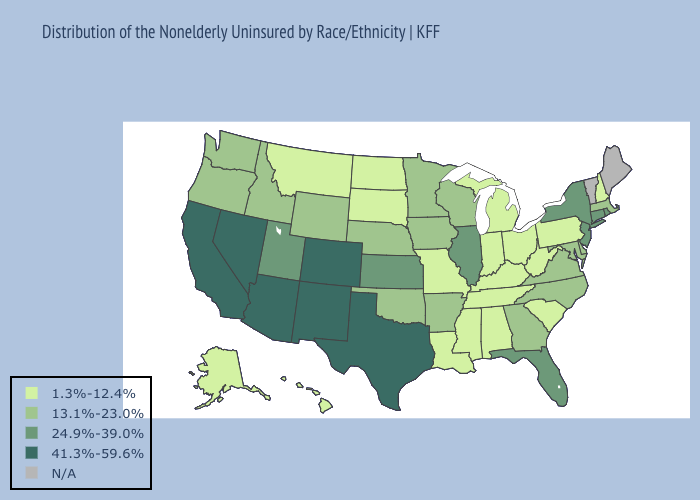Which states hav the highest value in the Northeast?
Answer briefly. Connecticut, New Jersey, New York, Rhode Island. Does Oregon have the highest value in the USA?
Short answer required. No. Name the states that have a value in the range 24.9%-39.0%?
Short answer required. Connecticut, Florida, Illinois, Kansas, New Jersey, New York, Rhode Island, Utah. Is the legend a continuous bar?
Be succinct. No. What is the highest value in states that border North Dakota?
Concise answer only. 13.1%-23.0%. What is the highest value in the South ?
Be succinct. 41.3%-59.6%. Does Montana have the lowest value in the West?
Give a very brief answer. Yes. Which states hav the highest value in the West?
Short answer required. Arizona, California, Colorado, Nevada, New Mexico. What is the value of Rhode Island?
Write a very short answer. 24.9%-39.0%. What is the value of South Dakota?
Keep it brief. 1.3%-12.4%. Name the states that have a value in the range 13.1%-23.0%?
Keep it brief. Arkansas, Delaware, Georgia, Idaho, Iowa, Maryland, Massachusetts, Minnesota, Nebraska, North Carolina, Oklahoma, Oregon, Virginia, Washington, Wisconsin, Wyoming. How many symbols are there in the legend?
Write a very short answer. 5. What is the value of Montana?
Quick response, please. 1.3%-12.4%. Which states have the highest value in the USA?
Give a very brief answer. Arizona, California, Colorado, Nevada, New Mexico, Texas. 